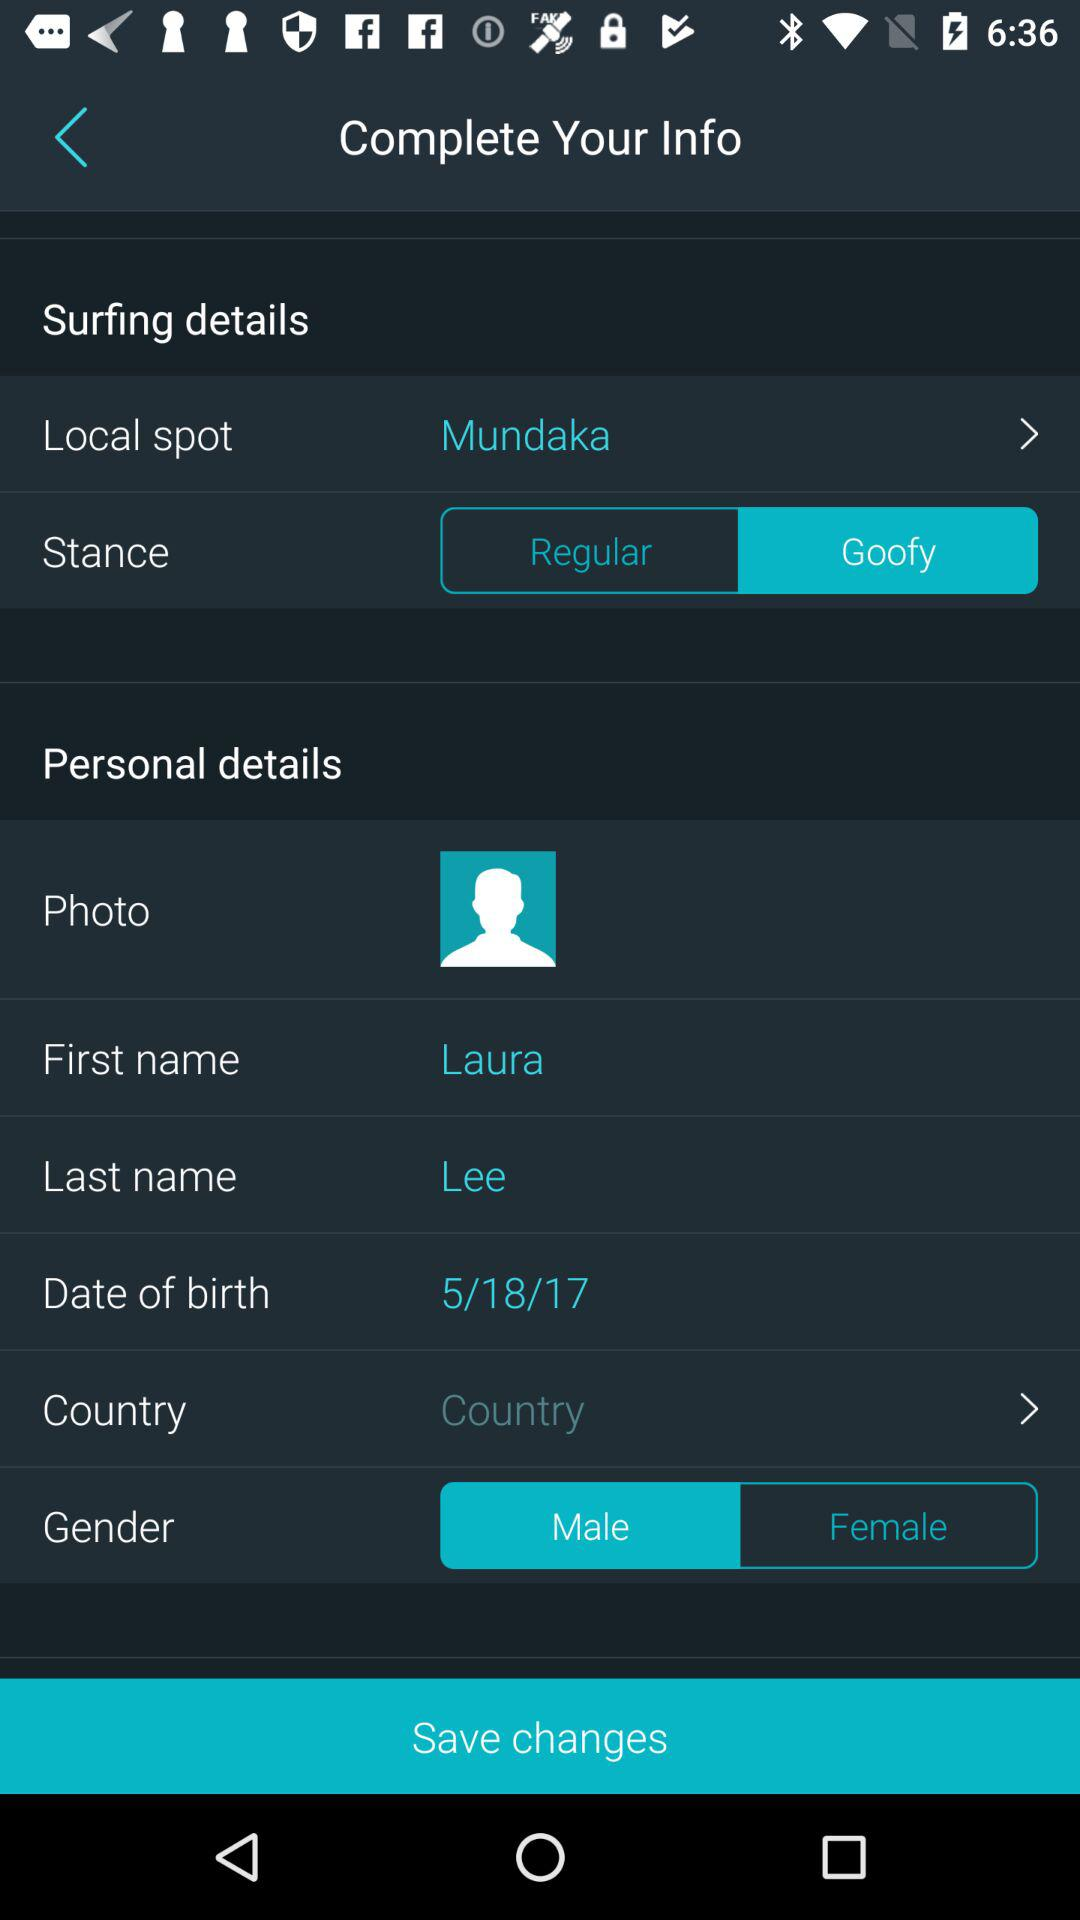What is the status of Stance? The status is "Goofy". 